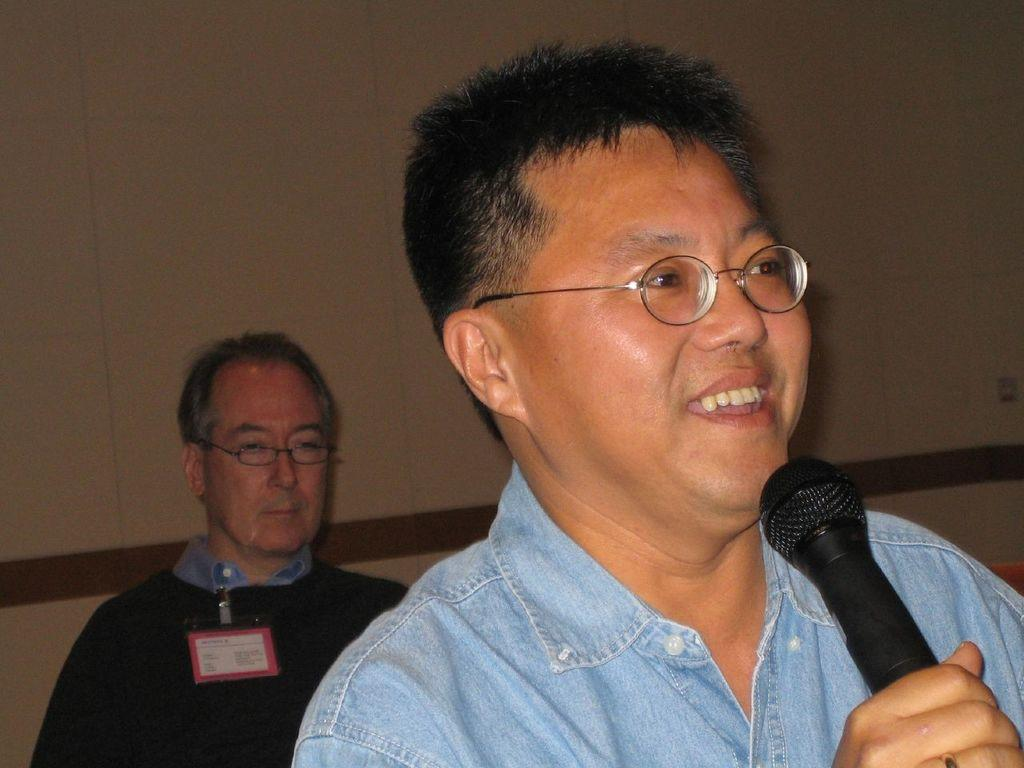What is the person in the image holding? The person is holding a microphone in the image. Can you describe the person's appearance? The person is wearing spectacles and is smiling. Is there anyone else visible in the image? Yes, there is another person visible in the background of the image. What can be seen in the background of the image? There is a wall in the background of the image. How does the person's wealth affect the ocean in the image? There is no ocean present in the image, and the person's wealth is not mentioned or depicted. What type of glove is the person wearing in the image? There is no glove visible on the person in the image. 